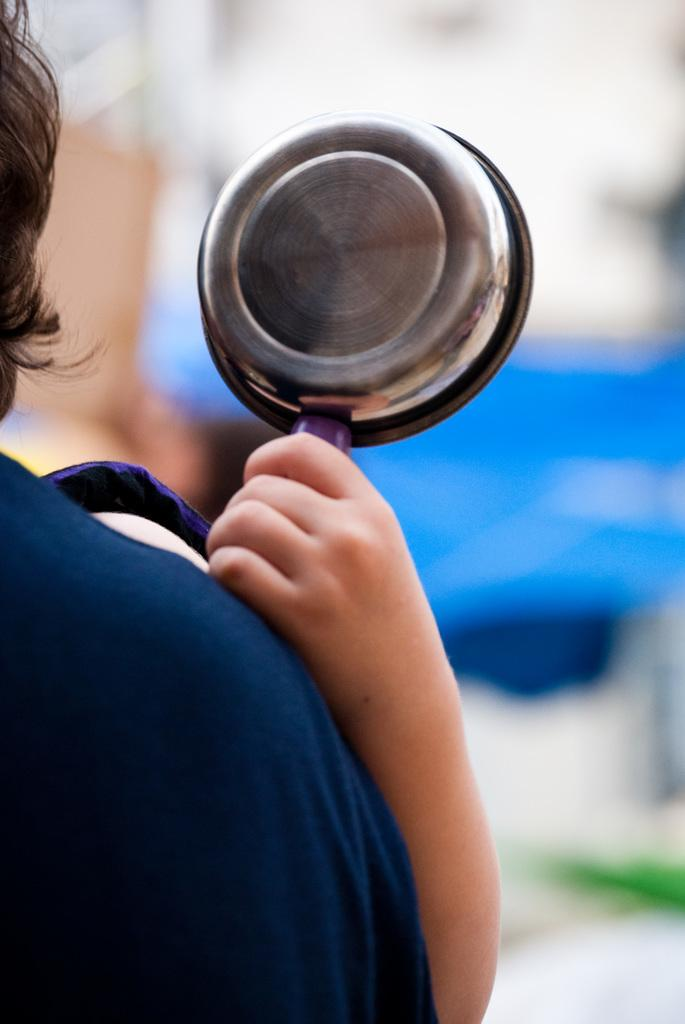What is the main subject of the image? There is a person wearing clothes in the image. What is the second person in the image doing? The second person is holding a pan in the image. Can you describe the background of the image? The background of the image is blurred. What type of ghost can be seen rubbing the person's leg in the image? There is no ghost or leg rubbing present in the image. 